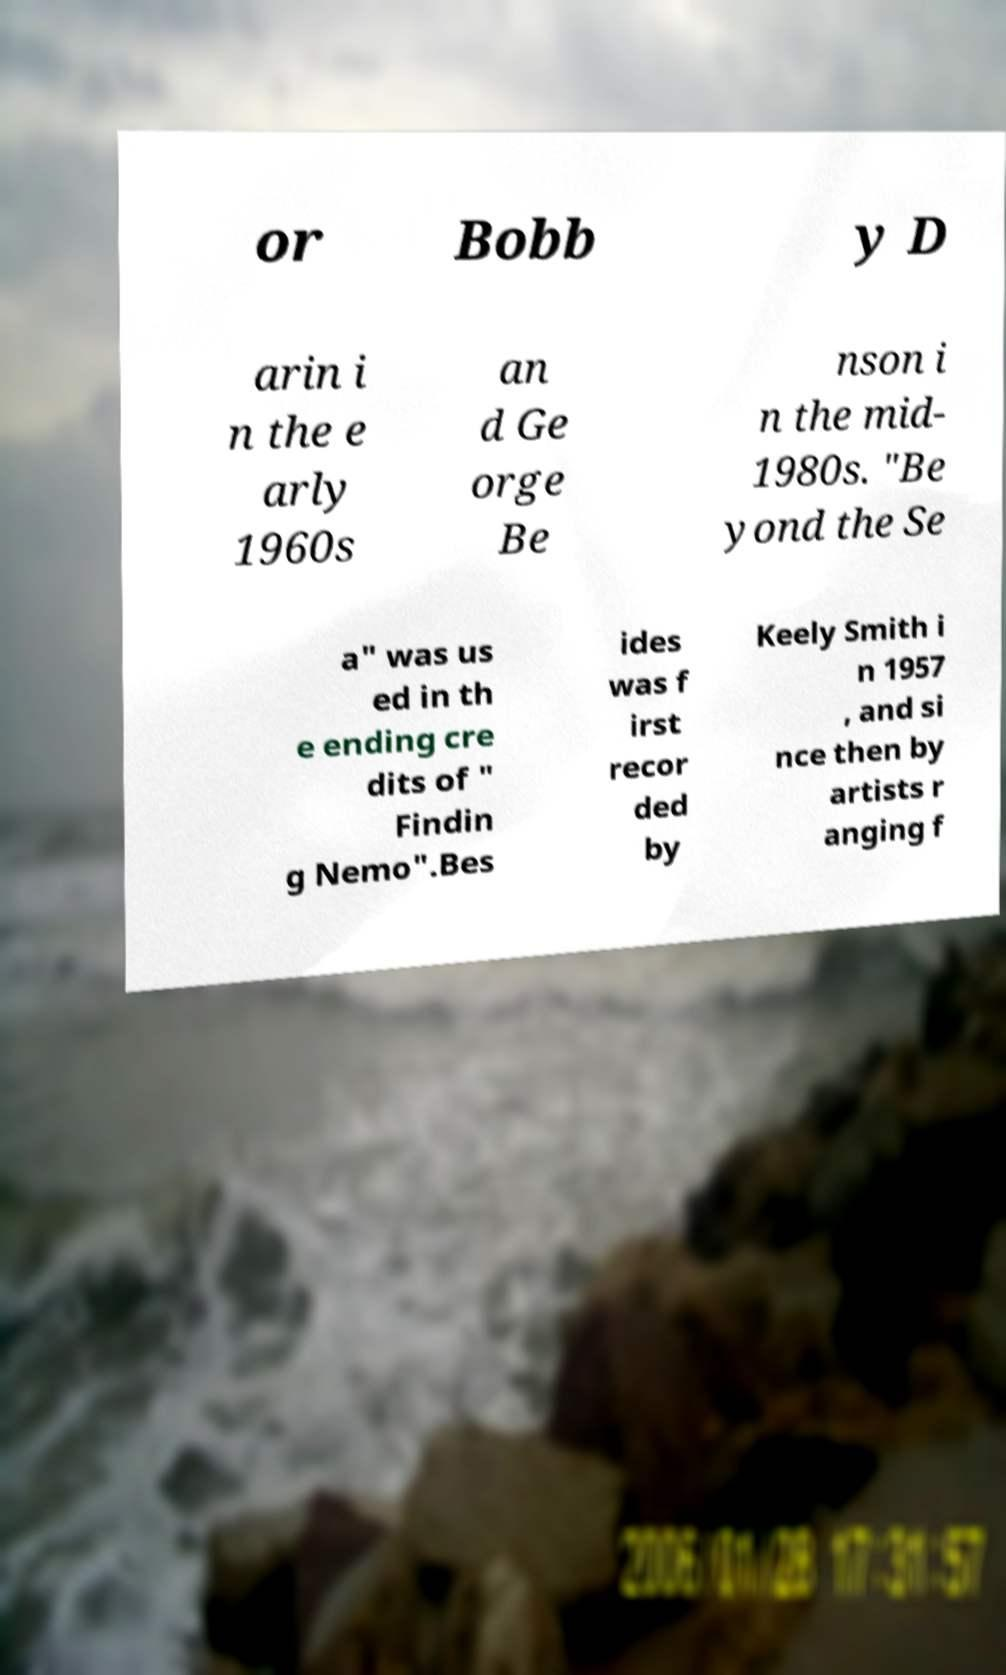There's text embedded in this image that I need extracted. Can you transcribe it verbatim? or Bobb y D arin i n the e arly 1960s an d Ge orge Be nson i n the mid- 1980s. "Be yond the Se a" was us ed in th e ending cre dits of " Findin g Nemo".Bes ides was f irst recor ded by Keely Smith i n 1957 , and si nce then by artists r anging f 